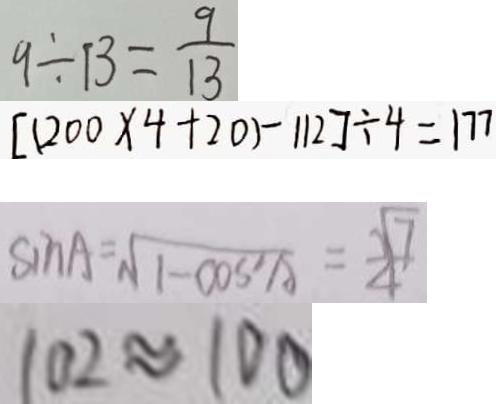<formula> <loc_0><loc_0><loc_500><loc_500>9 \div 1 3 = \frac { 9 } { 1 3 } 
 [ ( 2 0 0 \times 4 + 2 0 ) - 1 1 2 ] \div 4 = 1 7 7 
 \sin A = \sqrt { 1 - \cos ^ { 2 } A } = \frac { \sqrt { 7 } } { 4 } 
 1 0 2 \approx 1 0 0</formula> 